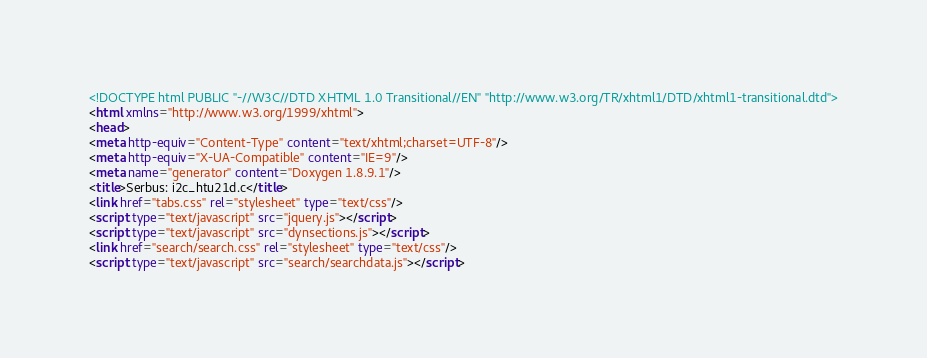Convert code to text. <code><loc_0><loc_0><loc_500><loc_500><_HTML_><!DOCTYPE html PUBLIC "-//W3C//DTD XHTML 1.0 Transitional//EN" "http://www.w3.org/TR/xhtml1/DTD/xhtml1-transitional.dtd">
<html xmlns="http://www.w3.org/1999/xhtml">
<head>
<meta http-equiv="Content-Type" content="text/xhtml;charset=UTF-8"/>
<meta http-equiv="X-UA-Compatible" content="IE=9"/>
<meta name="generator" content="Doxygen 1.8.9.1"/>
<title>Serbus: i2c_htu21d.c</title>
<link href="tabs.css" rel="stylesheet" type="text/css"/>
<script type="text/javascript" src="jquery.js"></script>
<script type="text/javascript" src="dynsections.js"></script>
<link href="search/search.css" rel="stylesheet" type="text/css"/>
<script type="text/javascript" src="search/searchdata.js"></script></code> 